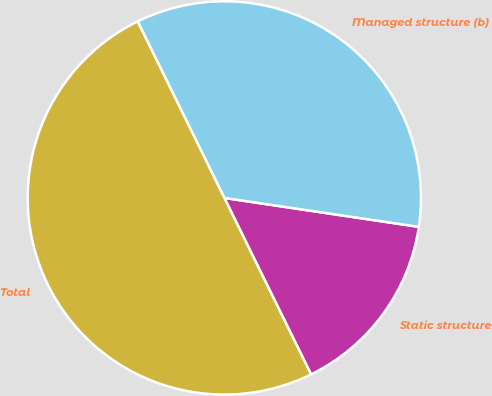Convert chart. <chart><loc_0><loc_0><loc_500><loc_500><pie_chart><fcel>Static structure<fcel>Managed structure (b)<fcel>Total<nl><fcel>15.38%<fcel>34.62%<fcel>50.0%<nl></chart> 